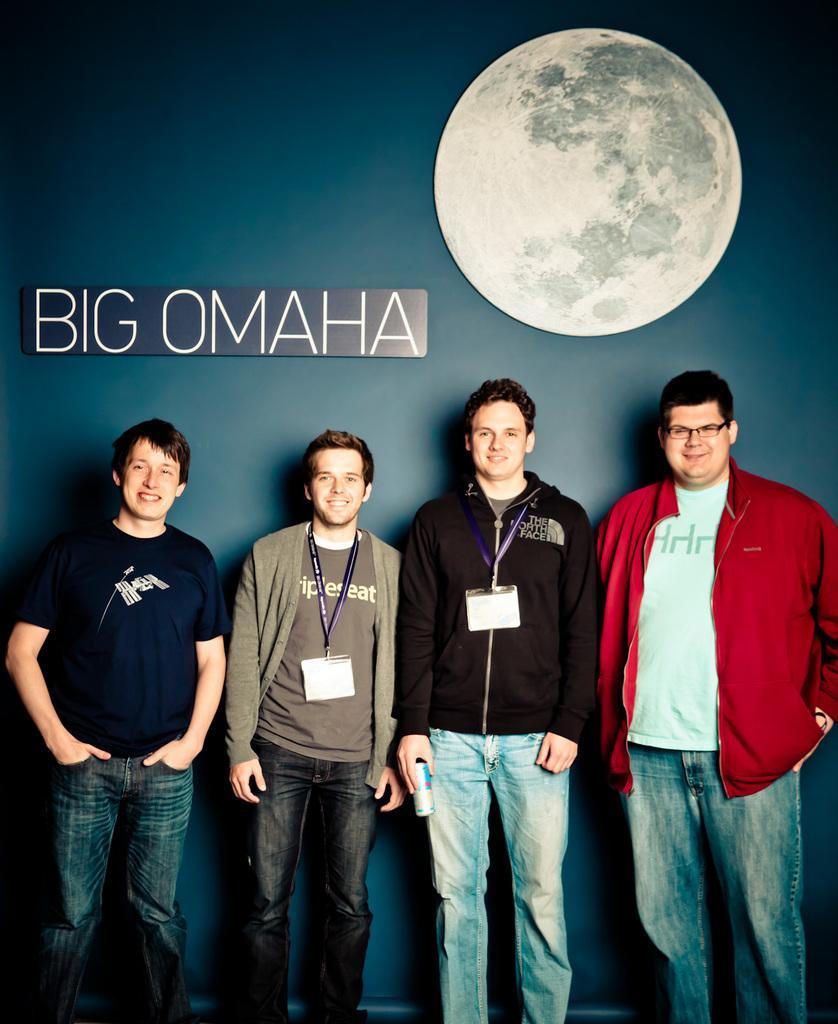Could you give a brief overview of what you see in this image? In this image we can see four persons standing and smiling and out of four persons, two persons are wearing the identity cards and one person is holding the coke tin. In the background we can see a plain colored wall and there is a text board and also the depiction of the moon attached to the wall. 